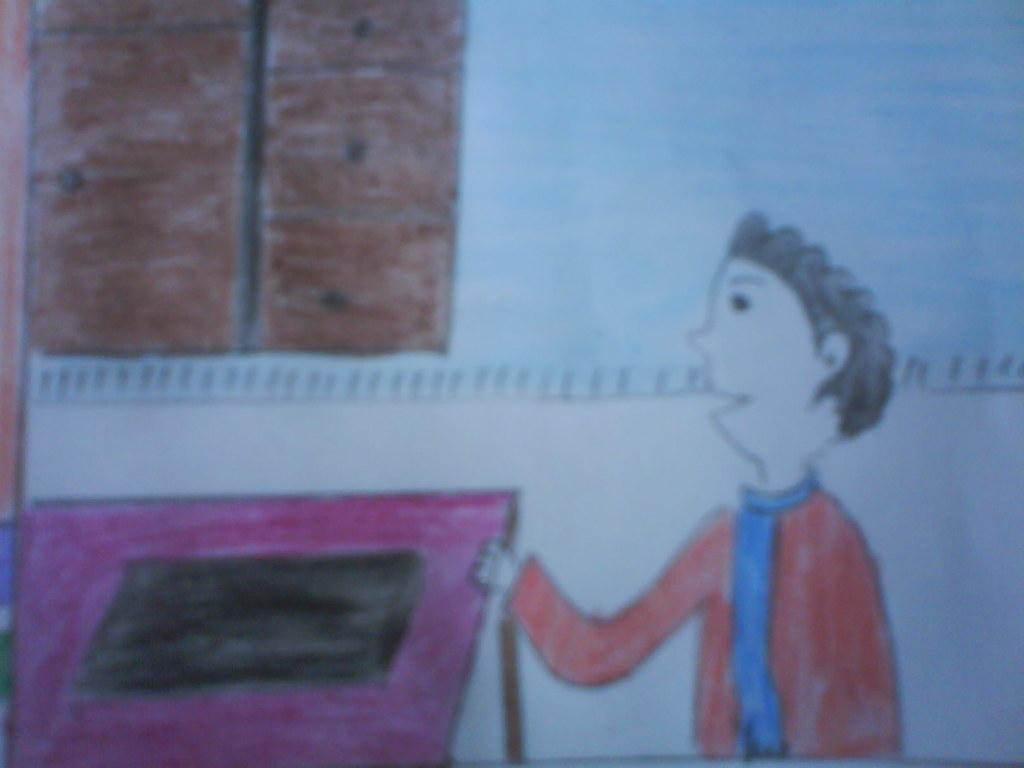What is shown in the image? The image contains a depiction of a person and a window. Can you describe the person in the image? Unfortunately, the image does not provide enough detail to describe the person. What can be seen through the window in the image? The image does not show what is visible through the window. What type of substance is being emitted from the volcano in the image? There is no volcano present in the image, so it is not possible to answer that question. 